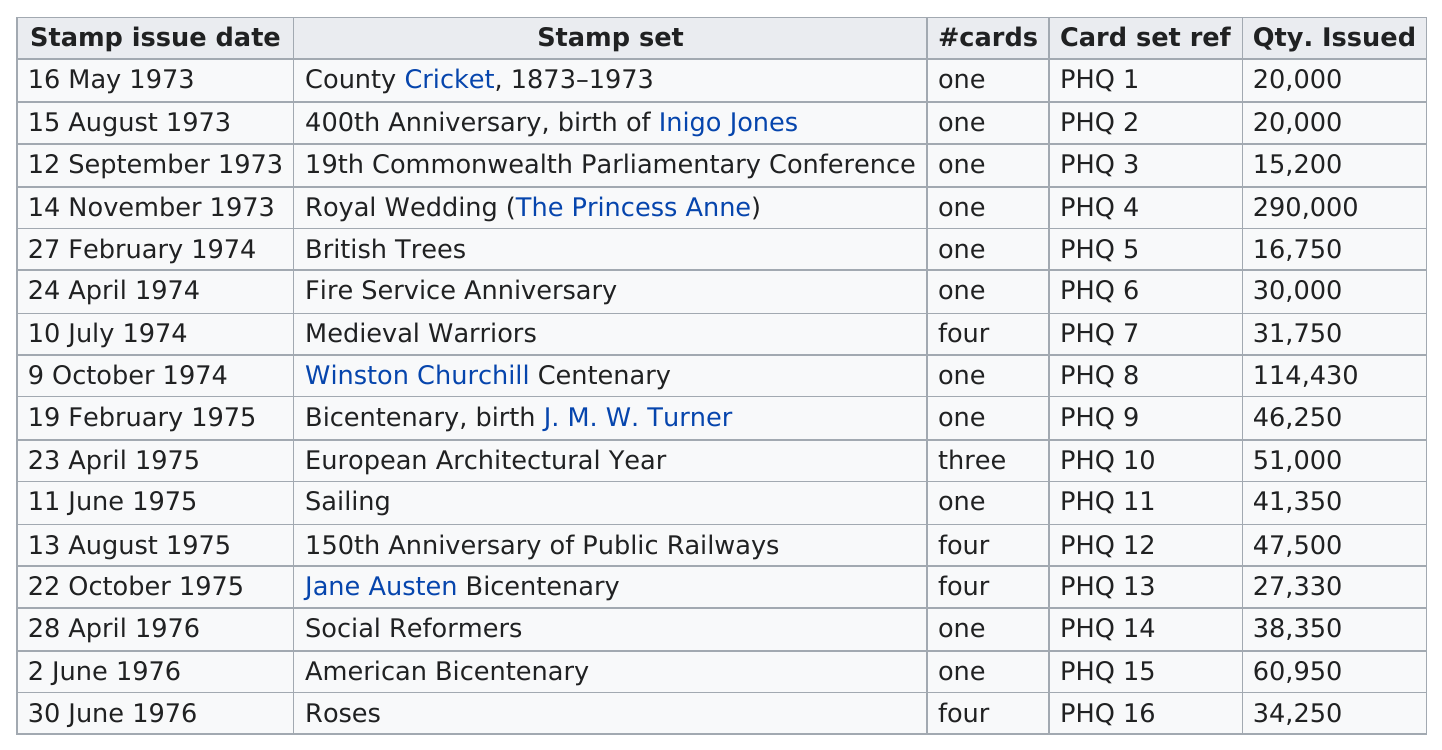Indicate a few pertinent items in this graphic. The European Architectural Year stamp set had only three cards in the set. The Royal Wedding (The Princess Anne) stamp set was the only one to have more than 200,000 issued. The Royal Wedding (The Princess Anne) stamp set had the greatest quantity issued out of all the stamp sets that were available. The bicentenary stamp sets include collections commemorating the bicentenary of J. M. W. Turner, Jane Austen, the American Bicentenary, and the Bicentenary itself. At least 50,000 stamp sets were issued for each of the 4 stamp sets that were available. 